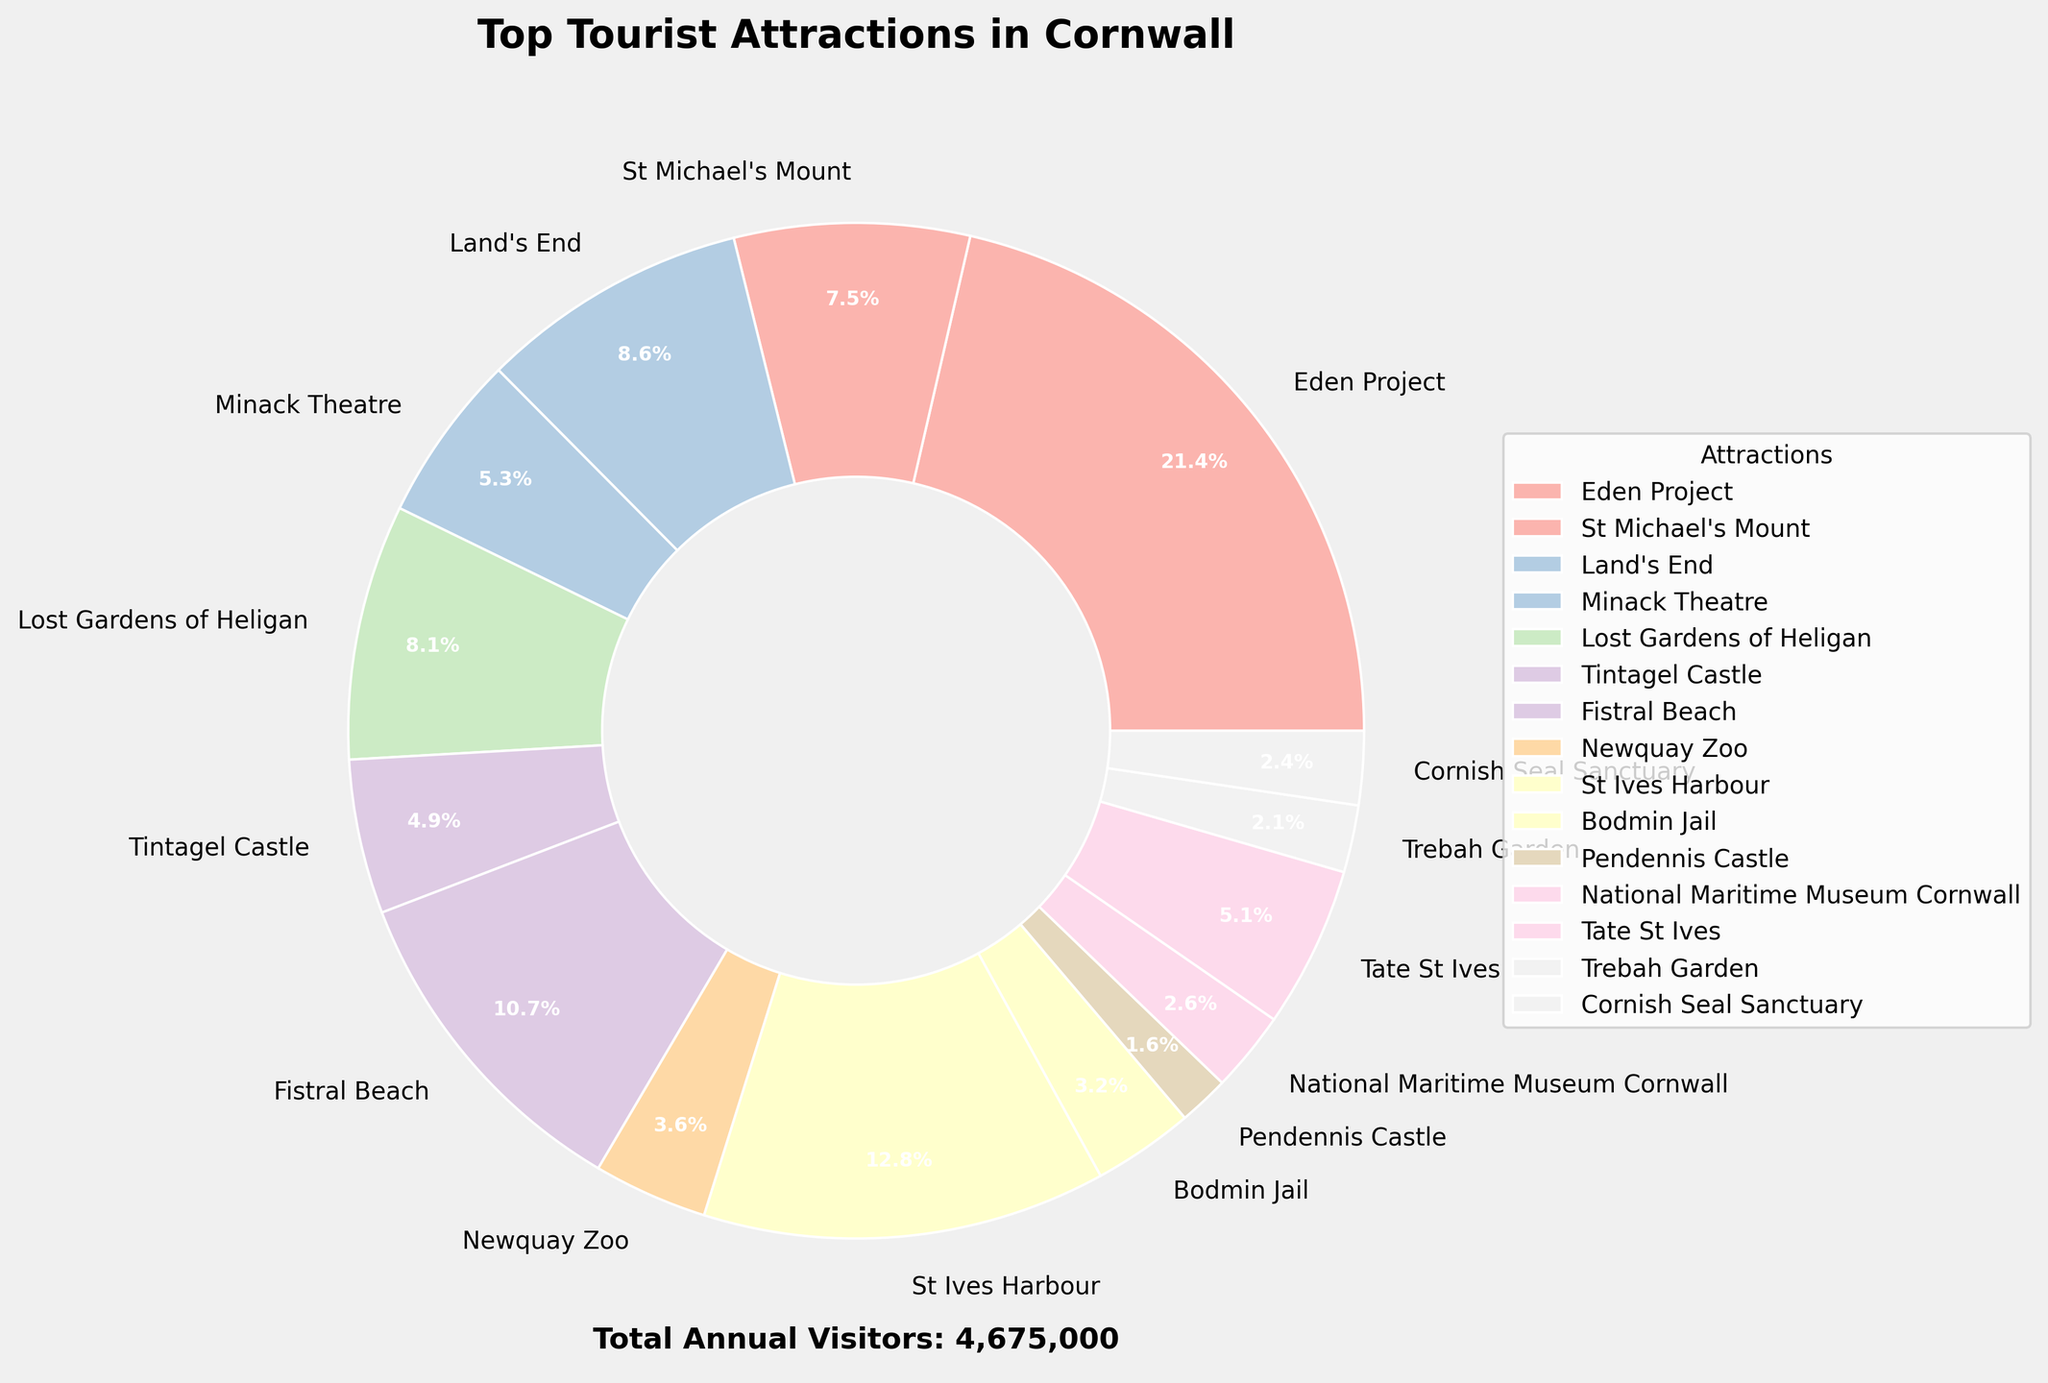Which attraction has the highest number of annual visitors and what percentage of the total does it represent? The Eden Project is labeled as the attraction with the highest number of annual visitors. The percentage is also displayed on the chart as part of the pie slice, showing 40.8%.
Answer: Eden Project; 40.8% Which attraction has the least number of annual visitors? By checking the pie slices and their labels, it’s clear that Pendennis Castle has the smallest slice, indicating it has the least number of annual visitors, representing 1.1%.
Answer: Pendennis Castle Compare the annual visitors of Land's End and Fistral Beach. Which one has more, and by how much? Land's End has 400,000 visitors while Fistral Beach has 500,000 visitors. The difference is 500,000 - 400,000 = 100,000.
Answer: Fistral Beach, 100,000 more visitors What is the percentage of the total annual visitors does St Ives Harbour represent? St Ives Harbour's slice on the pie chart is labeled with 24.5%, representing its percentage of the total annual visitors.
Answer: 24.5% How many attractions have more than 300,000 annual visitors? Observing the pie chart, Eden Project, Fistral Beach, St Ives Harbour, Land's End, Lost Gardens of Heligan, and St Michael's Mount each have more than 300,000 annual visitors. Counting these gives 6 attractions.
Answer: Six What is the combined total of annual visitors for Minack Theatre and Tintagel Castle? Minack Theatre has 250,000 visitors while Tintagel Castle has 230,000. Adding these two totals 250,000 + 230,000 = 480,000 visitors.
Answer: 480,000 Among all the attractions with fewer than 200,000 annual visitors, which has the highest number of visitors? The attractions with fewer than 200,000 visitors are Newquay Zoo (170,000), Bodmin Jail (150,000), Pendennis Castle (75,000), National Maritime Museum Cornwall (120,000), Trebah Garden (100,000), and Cornish Seal Sanctuary (110,000). Newquay Zoo has the highest number among them.
Answer: Newquay Zoo If the total visitor count for the Eden Project and St Michael's Mount is combined, what percentage of the overall total does this represent? Eden Project has 1,000,000 visitors and St Michael's Mount has 350,000. Their combined total is 1,000,000 + 350,000 = 1,350,000. The total number of visitors is 2,452,500. Thus, (1,350,000 / 2,452,500) * 100% = 55%.
Answer: 55% What's the difference in visitor numbers between the Lost Gardens of Heligan and Tintagel Castle? Lost Gardens of Heligan has 380,000 visitors, whereas Tintagel Castle has 230,000. The difference is 380,000 - 230,000 = 150,000 visitors.
Answer: 150,000 In terms of the total annual visitor count, what is the contribution percentage of the Newquay Zoo? Newquay Zoo's visitors are 170,000. The total number of visitors is 2,452,500. Thus, (170,000 / 2,452,500) * 100% = approximately 6.9%.
Answer: 6.9% 